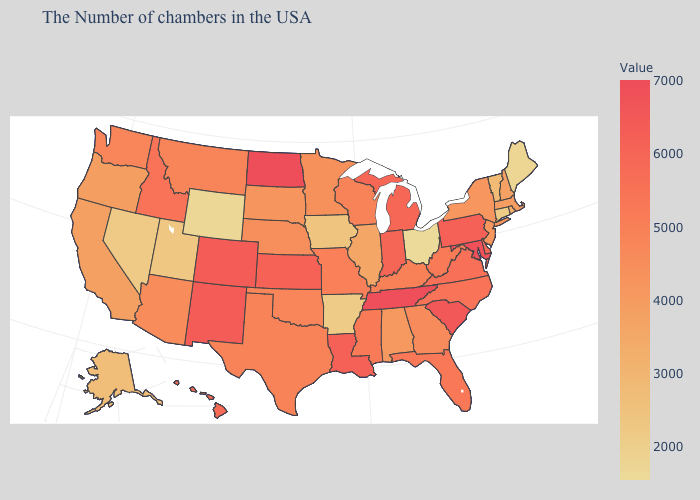Which states have the highest value in the USA?
Write a very short answer. North Dakota. Which states have the lowest value in the USA?
Give a very brief answer. Ohio. Does Kansas have the lowest value in the MidWest?
Quick response, please. No. Among the states that border Minnesota , does Iowa have the highest value?
Write a very short answer. No. Among the states that border Georgia , does Alabama have the lowest value?
Be succinct. Yes. Does Ohio have the lowest value in the USA?
Keep it brief. Yes. Is the legend a continuous bar?
Answer briefly. Yes. Among the states that border Iowa , which have the lowest value?
Answer briefly. Illinois. Does Tennessee have the lowest value in the South?
Answer briefly. No. Among the states that border Maryland , does Pennsylvania have the highest value?
Short answer required. Yes. Does the map have missing data?
Answer briefly. No. 